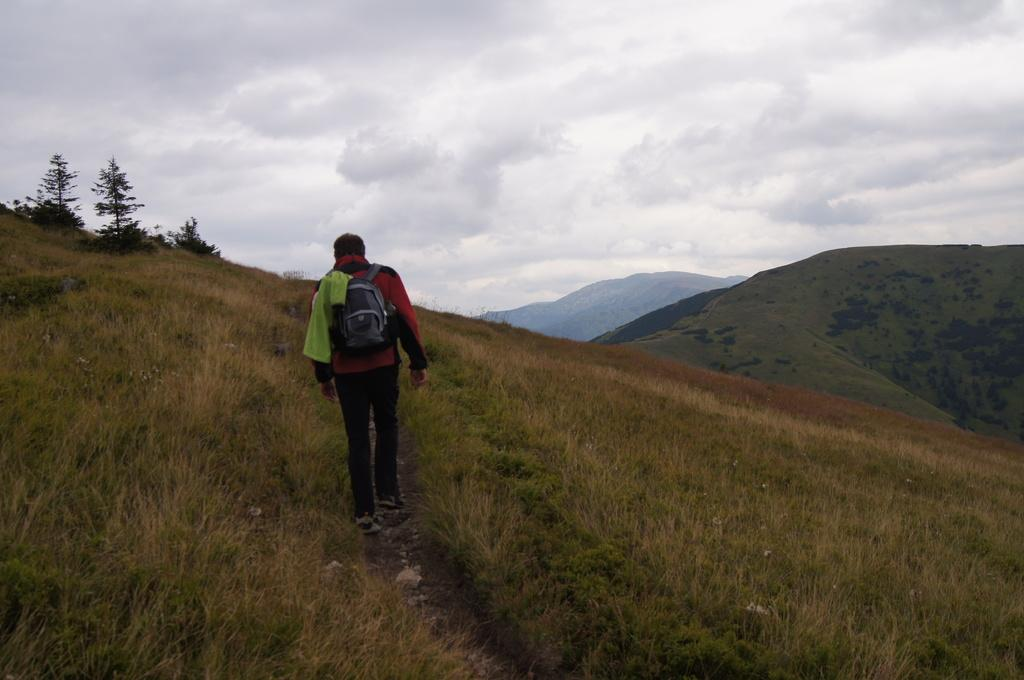What can be seen in the background of the image? The sky is visible in the background of the image. What type of terrain is present in the image? There are hills and grass in the image. What other natural elements are present in the image? There are trees in the image. Who is present in the image? There is a person in the image. What is the person wearing? The person is wearing a backpack and a jacket. What is the person doing in the image? The person is walking. Can you tell me how many matches the person is holding in the image? There are no matches present in the image. What is the person's desire while walking in the image? The image does not provide information about the person's desires or intentions. 